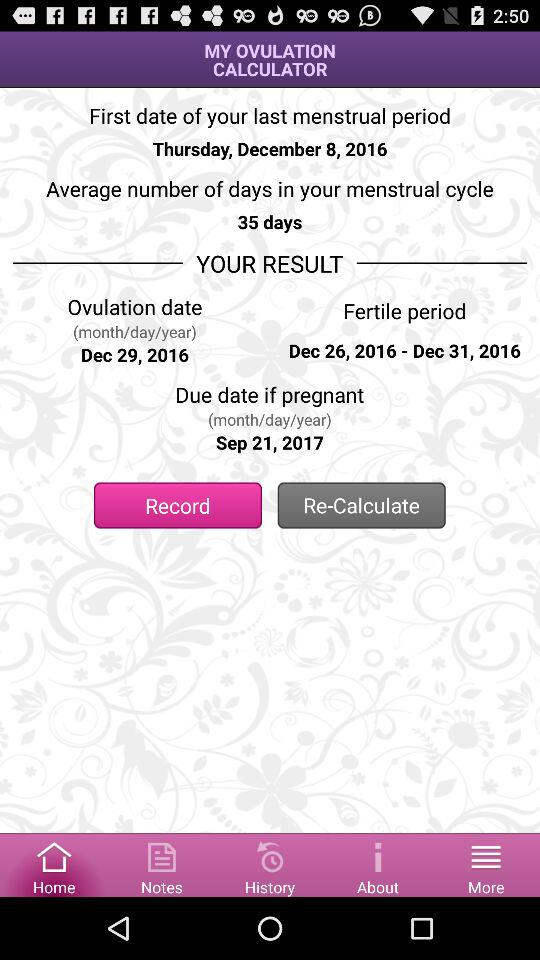What is the first date of the last menstrual period? The first date is Thursday, December 8, 2016. 